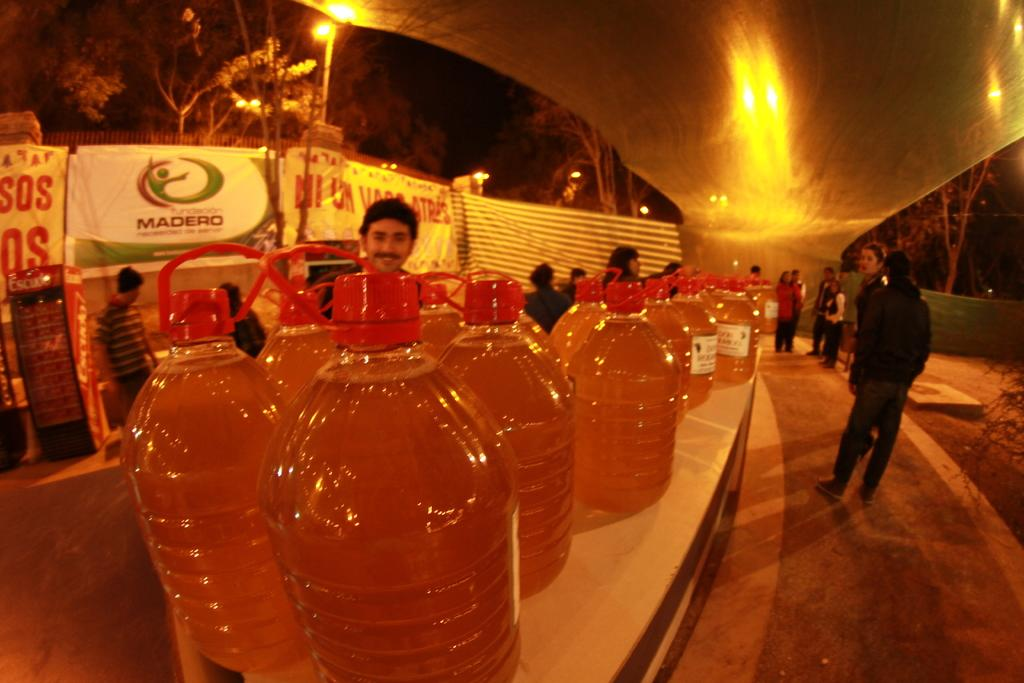<image>
Offer a succinct explanation of the picture presented. A sign for Madero hangs behind a huge row of bottles with red caps. 